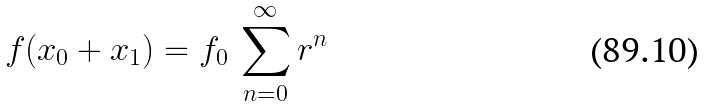Convert formula to latex. <formula><loc_0><loc_0><loc_500><loc_500>f ( x _ { 0 } + x _ { 1 } ) = f _ { 0 } \, \sum _ { n = 0 } ^ { \infty } r ^ { n }</formula> 